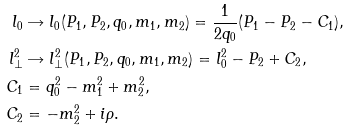Convert formula to latex. <formula><loc_0><loc_0><loc_500><loc_500>l _ { 0 } & \rightarrow l _ { 0 } ( P _ { 1 } , P _ { 2 } , q _ { 0 } , m _ { 1 } , m _ { 2 } ) = { \frac { 1 } { 2 q _ { 0 } } } ( P _ { 1 } - P _ { 2 } - C _ { 1 } ) , \\ l _ { \perp } ^ { 2 } & \rightarrow l _ { \perp } ^ { 2 } ( P _ { 1 } , P _ { 2 } , q _ { 0 } , m _ { 1 } , m _ { 2 } ) = l _ { 0 } ^ { 2 } - P _ { 2 } + C _ { 2 } , \\ C _ { 1 } & = q _ { 0 } ^ { 2 } - m _ { 1 } ^ { 2 } + m _ { 2 } ^ { 2 } , \\ C _ { 2 } & = - m _ { 2 } ^ { 2 } + i \rho .</formula> 